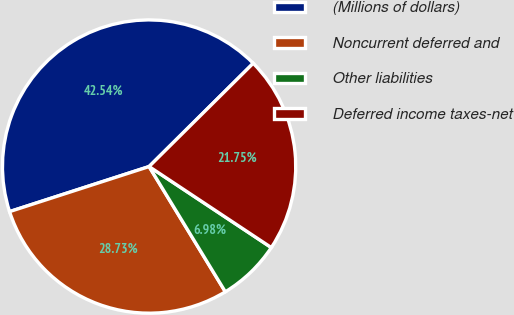Convert chart to OTSL. <chart><loc_0><loc_0><loc_500><loc_500><pie_chart><fcel>(Millions of dollars)<fcel>Noncurrent deferred and<fcel>Other liabilities<fcel>Deferred income taxes-net<nl><fcel>42.54%<fcel>28.73%<fcel>6.98%<fcel>21.75%<nl></chart> 